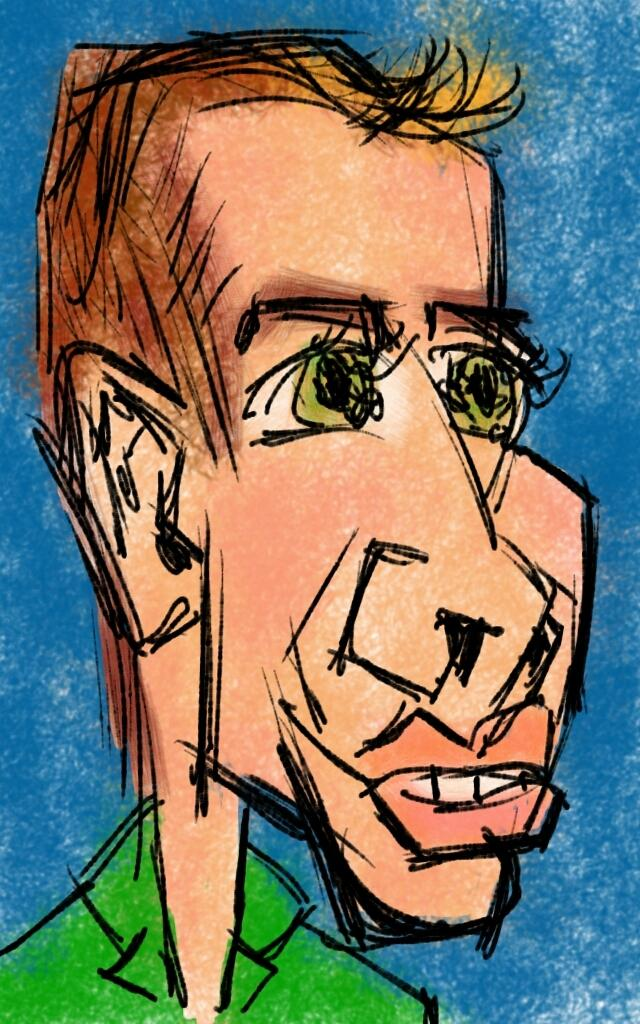What type of content is depicted in the image? There is a cartoon in the image. What color is predominantly used in the background of the image? The background color of the image is blue. What scientific experiment is being conducted in the image? There is no scientific experiment present in the image; it features a cartoon. Where is the drain located in the image? There is no drain present in the image. 